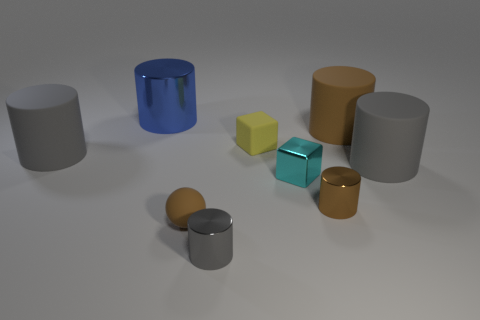There is a brown rubber thing left of the brown rubber cylinder; does it have the same size as the rubber cylinder on the left side of the small cyan metallic cube?
Provide a short and direct response. No. What is the size of the brown rubber object that is to the left of the gray object in front of the shiny cylinder that is right of the tiny yellow thing?
Offer a terse response. Small. What shape is the brown matte object to the left of the small shiny cylinder that is behind the brown rubber sphere?
Your answer should be compact. Sphere. There is a tiny metallic cylinder behind the sphere; does it have the same color as the small ball?
Provide a short and direct response. Yes. The matte thing that is left of the small yellow matte block and behind the cyan thing is what color?
Provide a short and direct response. Gray. Is there a cyan block made of the same material as the tiny gray object?
Keep it short and to the point. Yes. The blue metallic cylinder has what size?
Provide a succinct answer. Large. There is a gray matte cylinder in front of the gray cylinder to the left of the big blue cylinder; how big is it?
Provide a succinct answer. Large. There is a large brown object that is the same shape as the gray metal thing; what material is it?
Your answer should be very brief. Rubber. What number of tiny cyan shiny cubes are there?
Your answer should be very brief. 1. 